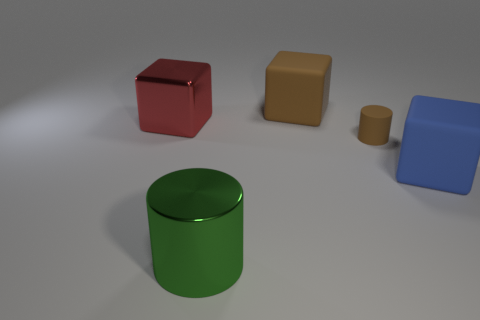Add 4 cyan spheres. How many objects exist? 9 Subtract all cubes. How many objects are left? 2 Add 4 large red cubes. How many large red cubes exist? 5 Subtract 0 gray balls. How many objects are left? 5 Subtract all matte things. Subtract all large cylinders. How many objects are left? 1 Add 2 metallic cylinders. How many metallic cylinders are left? 3 